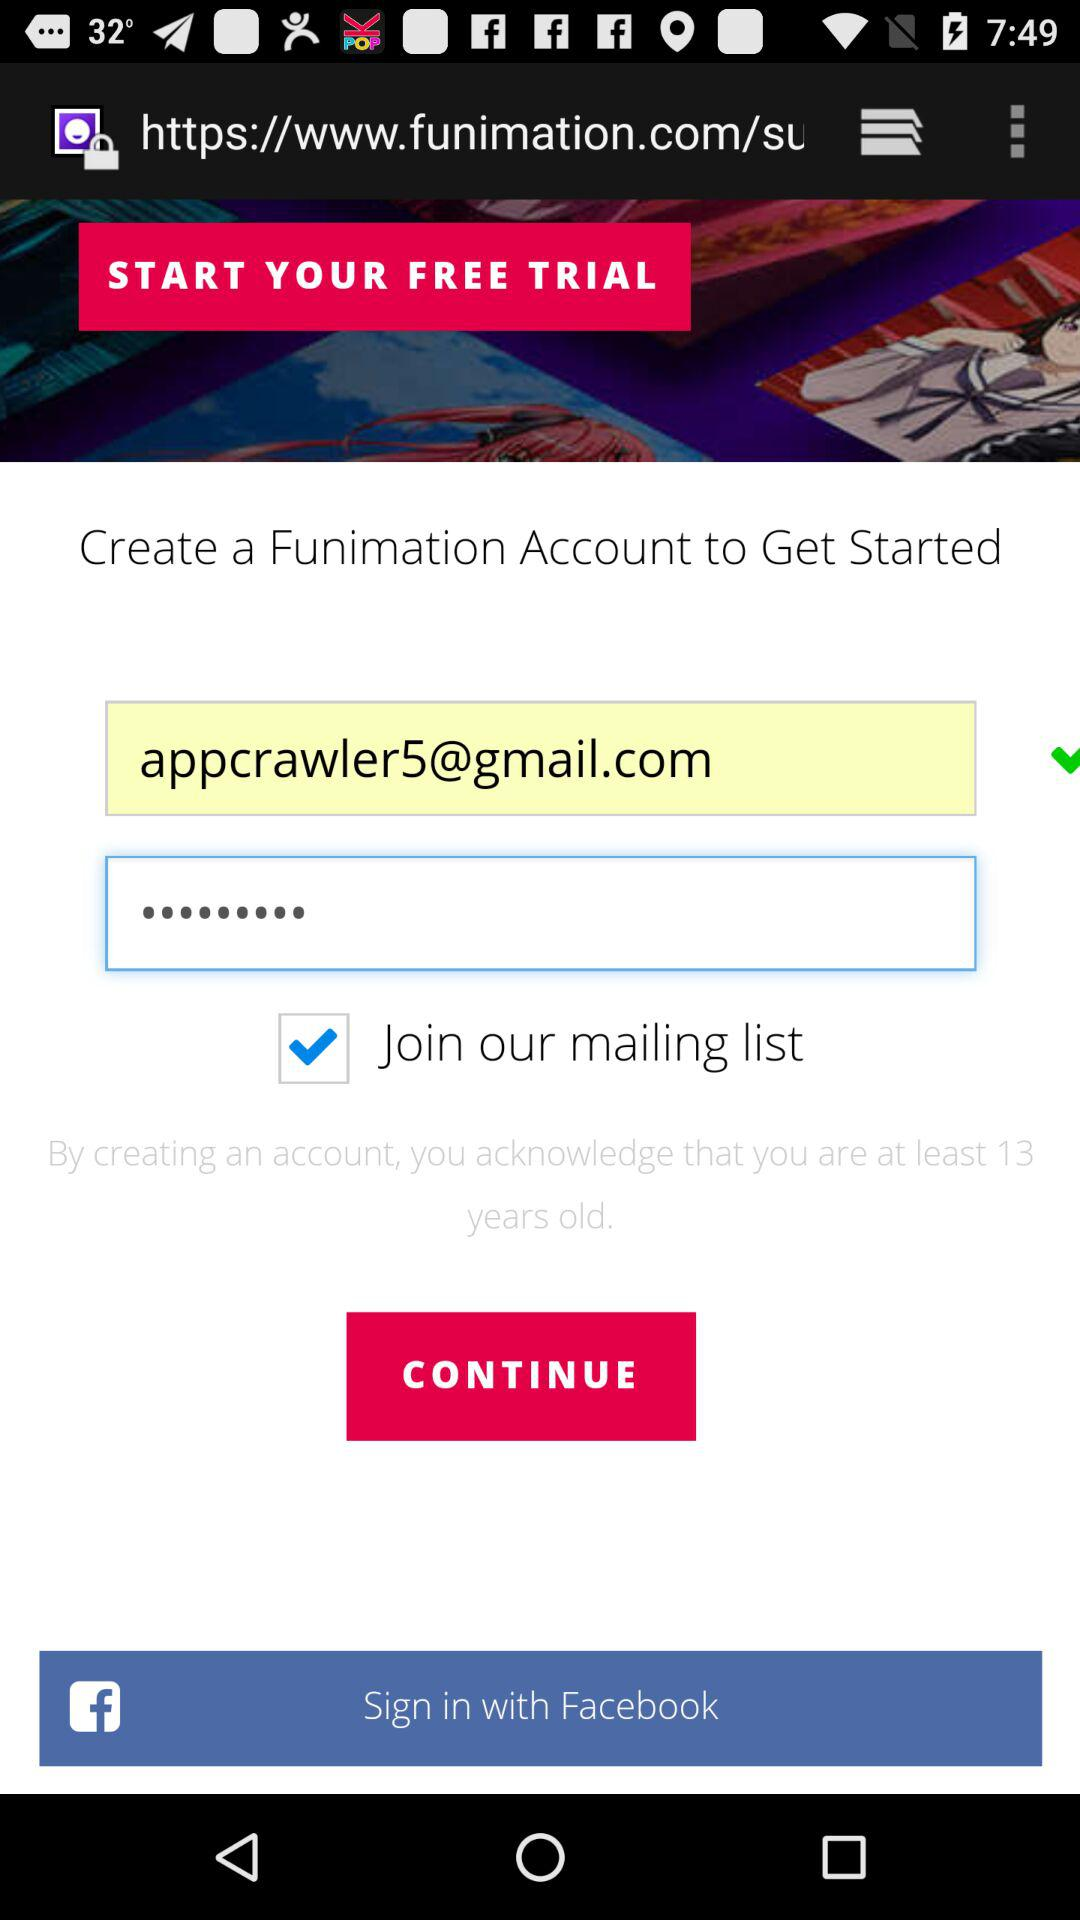How many text inputs have an email address in them?
Answer the question using a single word or phrase. 1 